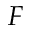<formula> <loc_0><loc_0><loc_500><loc_500>F</formula> 